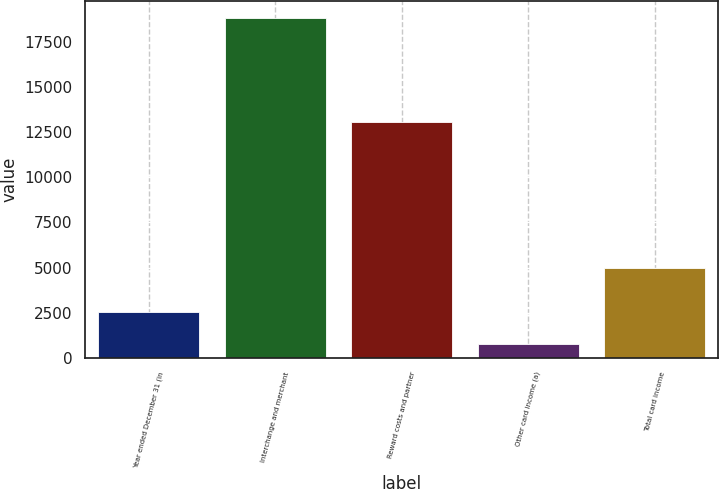<chart> <loc_0><loc_0><loc_500><loc_500><bar_chart><fcel>Year ended December 31 (in<fcel>Interchange and merchant<fcel>Reward costs and partner<fcel>Other card income (a)<fcel>Total card income<nl><fcel>2551.3<fcel>18808<fcel>13074<fcel>745<fcel>4989<nl></chart> 